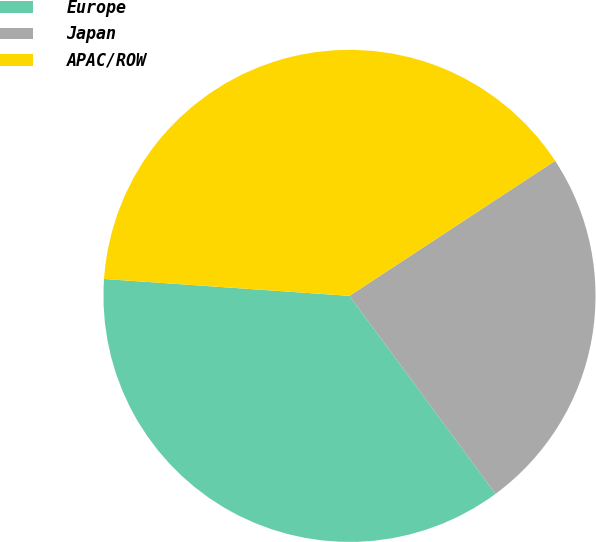Convert chart to OTSL. <chart><loc_0><loc_0><loc_500><loc_500><pie_chart><fcel>Europe<fcel>Japan<fcel>APAC/ROW<nl><fcel>36.21%<fcel>24.14%<fcel>39.66%<nl></chart> 